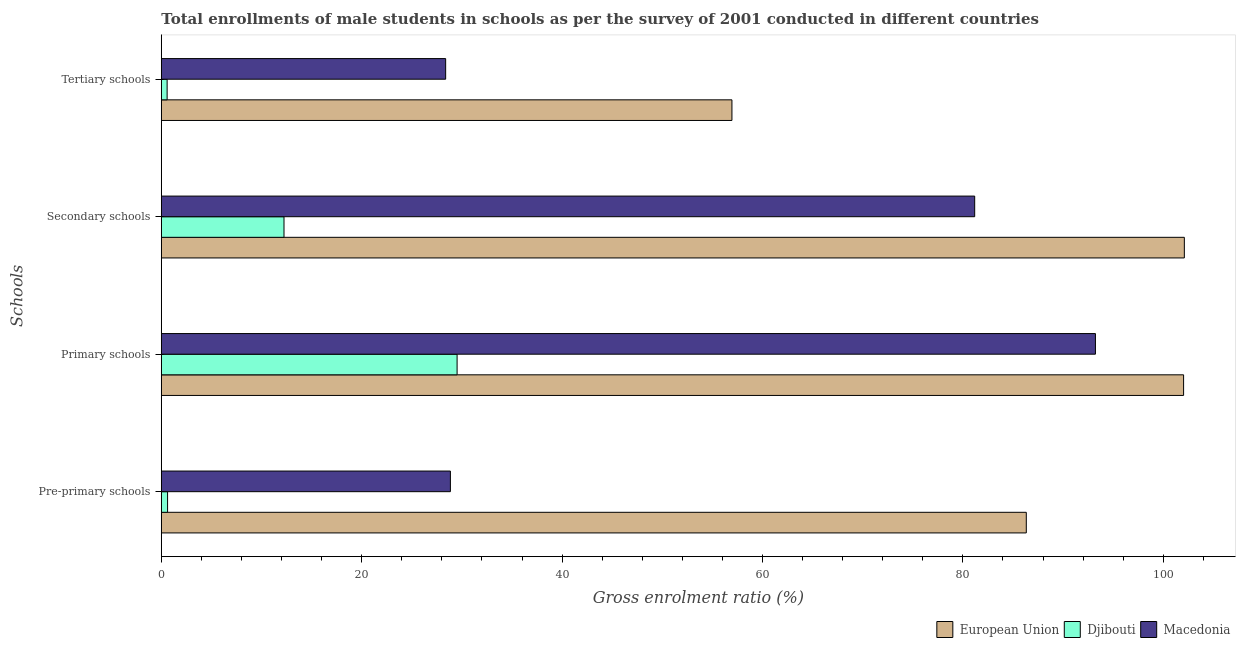How many groups of bars are there?
Offer a very short reply. 4. Are the number of bars per tick equal to the number of legend labels?
Give a very brief answer. Yes. Are the number of bars on each tick of the Y-axis equal?
Offer a terse response. Yes. How many bars are there on the 2nd tick from the top?
Offer a terse response. 3. How many bars are there on the 1st tick from the bottom?
Keep it short and to the point. 3. What is the label of the 1st group of bars from the top?
Give a very brief answer. Tertiary schools. What is the gross enrolment ratio(male) in pre-primary schools in Djibouti?
Offer a very short reply. 0.63. Across all countries, what is the maximum gross enrolment ratio(male) in pre-primary schools?
Keep it short and to the point. 86.33. Across all countries, what is the minimum gross enrolment ratio(male) in primary schools?
Keep it short and to the point. 29.52. In which country was the gross enrolment ratio(male) in primary schools maximum?
Provide a short and direct response. European Union. In which country was the gross enrolment ratio(male) in pre-primary schools minimum?
Provide a succinct answer. Djibouti. What is the total gross enrolment ratio(male) in pre-primary schools in the graph?
Offer a very short reply. 115.81. What is the difference between the gross enrolment ratio(male) in pre-primary schools in European Union and that in Djibouti?
Your answer should be compact. 85.71. What is the difference between the gross enrolment ratio(male) in secondary schools in Djibouti and the gross enrolment ratio(male) in tertiary schools in Macedonia?
Your response must be concise. -16.13. What is the average gross enrolment ratio(male) in primary schools per country?
Provide a short and direct response. 74.93. What is the difference between the gross enrolment ratio(male) in pre-primary schools and gross enrolment ratio(male) in primary schools in Macedonia?
Keep it short and to the point. -64.38. What is the ratio of the gross enrolment ratio(male) in pre-primary schools in European Union to that in Macedonia?
Your response must be concise. 2.99. What is the difference between the highest and the second highest gross enrolment ratio(male) in tertiary schools?
Your answer should be compact. 28.57. What is the difference between the highest and the lowest gross enrolment ratio(male) in tertiary schools?
Provide a short and direct response. 56.37. In how many countries, is the gross enrolment ratio(male) in tertiary schools greater than the average gross enrolment ratio(male) in tertiary schools taken over all countries?
Give a very brief answer. 1. What does the 2nd bar from the top in Pre-primary schools represents?
Your response must be concise. Djibouti. What does the 1st bar from the bottom in Pre-primary schools represents?
Make the answer very short. European Union. How many bars are there?
Provide a succinct answer. 12. Are all the bars in the graph horizontal?
Offer a very short reply. Yes. How many countries are there in the graph?
Provide a succinct answer. 3. Does the graph contain grids?
Your answer should be very brief. No. How many legend labels are there?
Give a very brief answer. 3. How are the legend labels stacked?
Offer a very short reply. Horizontal. What is the title of the graph?
Give a very brief answer. Total enrollments of male students in schools as per the survey of 2001 conducted in different countries. Does "Uganda" appear as one of the legend labels in the graph?
Provide a succinct answer. No. What is the label or title of the Y-axis?
Provide a short and direct response. Schools. What is the Gross enrolment ratio (%) of European Union in Pre-primary schools?
Your response must be concise. 86.33. What is the Gross enrolment ratio (%) of Djibouti in Pre-primary schools?
Give a very brief answer. 0.63. What is the Gross enrolment ratio (%) in Macedonia in Pre-primary schools?
Provide a succinct answer. 28.85. What is the Gross enrolment ratio (%) of European Union in Primary schools?
Provide a succinct answer. 102.03. What is the Gross enrolment ratio (%) of Djibouti in Primary schools?
Ensure brevity in your answer.  29.52. What is the Gross enrolment ratio (%) of Macedonia in Primary schools?
Your answer should be very brief. 93.23. What is the Gross enrolment ratio (%) of European Union in Secondary schools?
Provide a succinct answer. 102.11. What is the Gross enrolment ratio (%) of Djibouti in Secondary schools?
Give a very brief answer. 12.24. What is the Gross enrolment ratio (%) of Macedonia in Secondary schools?
Provide a succinct answer. 81.18. What is the Gross enrolment ratio (%) of European Union in Tertiary schools?
Give a very brief answer. 56.95. What is the Gross enrolment ratio (%) of Djibouti in Tertiary schools?
Your answer should be very brief. 0.58. What is the Gross enrolment ratio (%) of Macedonia in Tertiary schools?
Offer a terse response. 28.38. Across all Schools, what is the maximum Gross enrolment ratio (%) in European Union?
Keep it short and to the point. 102.11. Across all Schools, what is the maximum Gross enrolment ratio (%) of Djibouti?
Keep it short and to the point. 29.52. Across all Schools, what is the maximum Gross enrolment ratio (%) in Macedonia?
Your answer should be very brief. 93.23. Across all Schools, what is the minimum Gross enrolment ratio (%) in European Union?
Make the answer very short. 56.95. Across all Schools, what is the minimum Gross enrolment ratio (%) in Djibouti?
Offer a very short reply. 0.58. Across all Schools, what is the minimum Gross enrolment ratio (%) in Macedonia?
Offer a very short reply. 28.38. What is the total Gross enrolment ratio (%) in European Union in the graph?
Provide a succinct answer. 347.42. What is the total Gross enrolment ratio (%) of Djibouti in the graph?
Your response must be concise. 42.97. What is the total Gross enrolment ratio (%) in Macedonia in the graph?
Your answer should be compact. 231.64. What is the difference between the Gross enrolment ratio (%) in European Union in Pre-primary schools and that in Primary schools?
Offer a very short reply. -15.7. What is the difference between the Gross enrolment ratio (%) of Djibouti in Pre-primary schools and that in Primary schools?
Keep it short and to the point. -28.9. What is the difference between the Gross enrolment ratio (%) of Macedonia in Pre-primary schools and that in Primary schools?
Give a very brief answer. -64.38. What is the difference between the Gross enrolment ratio (%) of European Union in Pre-primary schools and that in Secondary schools?
Provide a succinct answer. -15.77. What is the difference between the Gross enrolment ratio (%) of Djibouti in Pre-primary schools and that in Secondary schools?
Your answer should be compact. -11.62. What is the difference between the Gross enrolment ratio (%) of Macedonia in Pre-primary schools and that in Secondary schools?
Keep it short and to the point. -52.33. What is the difference between the Gross enrolment ratio (%) in European Union in Pre-primary schools and that in Tertiary schools?
Keep it short and to the point. 29.38. What is the difference between the Gross enrolment ratio (%) of Djibouti in Pre-primary schools and that in Tertiary schools?
Provide a succinct answer. 0.05. What is the difference between the Gross enrolment ratio (%) in Macedonia in Pre-primary schools and that in Tertiary schools?
Provide a short and direct response. 0.47. What is the difference between the Gross enrolment ratio (%) of European Union in Primary schools and that in Secondary schools?
Provide a short and direct response. -0.07. What is the difference between the Gross enrolment ratio (%) in Djibouti in Primary schools and that in Secondary schools?
Keep it short and to the point. 17.28. What is the difference between the Gross enrolment ratio (%) of Macedonia in Primary schools and that in Secondary schools?
Keep it short and to the point. 12.05. What is the difference between the Gross enrolment ratio (%) of European Union in Primary schools and that in Tertiary schools?
Your answer should be compact. 45.08. What is the difference between the Gross enrolment ratio (%) in Djibouti in Primary schools and that in Tertiary schools?
Keep it short and to the point. 28.94. What is the difference between the Gross enrolment ratio (%) in Macedonia in Primary schools and that in Tertiary schools?
Provide a short and direct response. 64.85. What is the difference between the Gross enrolment ratio (%) in European Union in Secondary schools and that in Tertiary schools?
Your response must be concise. 45.15. What is the difference between the Gross enrolment ratio (%) of Djibouti in Secondary schools and that in Tertiary schools?
Offer a terse response. 11.66. What is the difference between the Gross enrolment ratio (%) of Macedonia in Secondary schools and that in Tertiary schools?
Your answer should be compact. 52.8. What is the difference between the Gross enrolment ratio (%) in European Union in Pre-primary schools and the Gross enrolment ratio (%) in Djibouti in Primary schools?
Give a very brief answer. 56.81. What is the difference between the Gross enrolment ratio (%) of European Union in Pre-primary schools and the Gross enrolment ratio (%) of Macedonia in Primary schools?
Offer a very short reply. -6.9. What is the difference between the Gross enrolment ratio (%) in Djibouti in Pre-primary schools and the Gross enrolment ratio (%) in Macedonia in Primary schools?
Provide a succinct answer. -92.61. What is the difference between the Gross enrolment ratio (%) in European Union in Pre-primary schools and the Gross enrolment ratio (%) in Djibouti in Secondary schools?
Provide a short and direct response. 74.09. What is the difference between the Gross enrolment ratio (%) of European Union in Pre-primary schools and the Gross enrolment ratio (%) of Macedonia in Secondary schools?
Your response must be concise. 5.15. What is the difference between the Gross enrolment ratio (%) of Djibouti in Pre-primary schools and the Gross enrolment ratio (%) of Macedonia in Secondary schools?
Provide a succinct answer. -80.56. What is the difference between the Gross enrolment ratio (%) in European Union in Pre-primary schools and the Gross enrolment ratio (%) in Djibouti in Tertiary schools?
Keep it short and to the point. 85.75. What is the difference between the Gross enrolment ratio (%) of European Union in Pre-primary schools and the Gross enrolment ratio (%) of Macedonia in Tertiary schools?
Make the answer very short. 57.95. What is the difference between the Gross enrolment ratio (%) in Djibouti in Pre-primary schools and the Gross enrolment ratio (%) in Macedonia in Tertiary schools?
Give a very brief answer. -27.75. What is the difference between the Gross enrolment ratio (%) in European Union in Primary schools and the Gross enrolment ratio (%) in Djibouti in Secondary schools?
Provide a succinct answer. 89.79. What is the difference between the Gross enrolment ratio (%) of European Union in Primary schools and the Gross enrolment ratio (%) of Macedonia in Secondary schools?
Give a very brief answer. 20.85. What is the difference between the Gross enrolment ratio (%) in Djibouti in Primary schools and the Gross enrolment ratio (%) in Macedonia in Secondary schools?
Offer a very short reply. -51.66. What is the difference between the Gross enrolment ratio (%) of European Union in Primary schools and the Gross enrolment ratio (%) of Djibouti in Tertiary schools?
Make the answer very short. 101.45. What is the difference between the Gross enrolment ratio (%) in European Union in Primary schools and the Gross enrolment ratio (%) in Macedonia in Tertiary schools?
Your answer should be compact. 73.65. What is the difference between the Gross enrolment ratio (%) in Djibouti in Primary schools and the Gross enrolment ratio (%) in Macedonia in Tertiary schools?
Ensure brevity in your answer.  1.14. What is the difference between the Gross enrolment ratio (%) in European Union in Secondary schools and the Gross enrolment ratio (%) in Djibouti in Tertiary schools?
Your answer should be compact. 101.53. What is the difference between the Gross enrolment ratio (%) in European Union in Secondary schools and the Gross enrolment ratio (%) in Macedonia in Tertiary schools?
Make the answer very short. 73.73. What is the difference between the Gross enrolment ratio (%) in Djibouti in Secondary schools and the Gross enrolment ratio (%) in Macedonia in Tertiary schools?
Make the answer very short. -16.13. What is the average Gross enrolment ratio (%) in European Union per Schools?
Provide a succinct answer. 86.86. What is the average Gross enrolment ratio (%) of Djibouti per Schools?
Make the answer very short. 10.74. What is the average Gross enrolment ratio (%) of Macedonia per Schools?
Ensure brevity in your answer.  57.91. What is the difference between the Gross enrolment ratio (%) of European Union and Gross enrolment ratio (%) of Djibouti in Pre-primary schools?
Make the answer very short. 85.71. What is the difference between the Gross enrolment ratio (%) of European Union and Gross enrolment ratio (%) of Macedonia in Pre-primary schools?
Offer a terse response. 57.48. What is the difference between the Gross enrolment ratio (%) of Djibouti and Gross enrolment ratio (%) of Macedonia in Pre-primary schools?
Keep it short and to the point. -28.23. What is the difference between the Gross enrolment ratio (%) of European Union and Gross enrolment ratio (%) of Djibouti in Primary schools?
Give a very brief answer. 72.51. What is the difference between the Gross enrolment ratio (%) of European Union and Gross enrolment ratio (%) of Macedonia in Primary schools?
Ensure brevity in your answer.  8.8. What is the difference between the Gross enrolment ratio (%) of Djibouti and Gross enrolment ratio (%) of Macedonia in Primary schools?
Your response must be concise. -63.71. What is the difference between the Gross enrolment ratio (%) in European Union and Gross enrolment ratio (%) in Djibouti in Secondary schools?
Provide a succinct answer. 89.86. What is the difference between the Gross enrolment ratio (%) of European Union and Gross enrolment ratio (%) of Macedonia in Secondary schools?
Ensure brevity in your answer.  20.93. What is the difference between the Gross enrolment ratio (%) of Djibouti and Gross enrolment ratio (%) of Macedonia in Secondary schools?
Offer a terse response. -68.94. What is the difference between the Gross enrolment ratio (%) in European Union and Gross enrolment ratio (%) in Djibouti in Tertiary schools?
Your answer should be very brief. 56.37. What is the difference between the Gross enrolment ratio (%) of European Union and Gross enrolment ratio (%) of Macedonia in Tertiary schools?
Your response must be concise. 28.57. What is the difference between the Gross enrolment ratio (%) of Djibouti and Gross enrolment ratio (%) of Macedonia in Tertiary schools?
Offer a terse response. -27.8. What is the ratio of the Gross enrolment ratio (%) in European Union in Pre-primary schools to that in Primary schools?
Your response must be concise. 0.85. What is the ratio of the Gross enrolment ratio (%) of Djibouti in Pre-primary schools to that in Primary schools?
Your answer should be very brief. 0.02. What is the ratio of the Gross enrolment ratio (%) in Macedonia in Pre-primary schools to that in Primary schools?
Give a very brief answer. 0.31. What is the ratio of the Gross enrolment ratio (%) of European Union in Pre-primary schools to that in Secondary schools?
Your answer should be very brief. 0.85. What is the ratio of the Gross enrolment ratio (%) of Djibouti in Pre-primary schools to that in Secondary schools?
Your response must be concise. 0.05. What is the ratio of the Gross enrolment ratio (%) in Macedonia in Pre-primary schools to that in Secondary schools?
Keep it short and to the point. 0.36. What is the ratio of the Gross enrolment ratio (%) in European Union in Pre-primary schools to that in Tertiary schools?
Provide a short and direct response. 1.52. What is the ratio of the Gross enrolment ratio (%) of Djibouti in Pre-primary schools to that in Tertiary schools?
Provide a succinct answer. 1.08. What is the ratio of the Gross enrolment ratio (%) of Macedonia in Pre-primary schools to that in Tertiary schools?
Keep it short and to the point. 1.02. What is the ratio of the Gross enrolment ratio (%) of Djibouti in Primary schools to that in Secondary schools?
Ensure brevity in your answer.  2.41. What is the ratio of the Gross enrolment ratio (%) in Macedonia in Primary schools to that in Secondary schools?
Make the answer very short. 1.15. What is the ratio of the Gross enrolment ratio (%) in European Union in Primary schools to that in Tertiary schools?
Give a very brief answer. 1.79. What is the ratio of the Gross enrolment ratio (%) in Djibouti in Primary schools to that in Tertiary schools?
Provide a succinct answer. 50.9. What is the ratio of the Gross enrolment ratio (%) of Macedonia in Primary schools to that in Tertiary schools?
Your response must be concise. 3.29. What is the ratio of the Gross enrolment ratio (%) of European Union in Secondary schools to that in Tertiary schools?
Give a very brief answer. 1.79. What is the ratio of the Gross enrolment ratio (%) of Djibouti in Secondary schools to that in Tertiary schools?
Your answer should be compact. 21.11. What is the ratio of the Gross enrolment ratio (%) in Macedonia in Secondary schools to that in Tertiary schools?
Offer a terse response. 2.86. What is the difference between the highest and the second highest Gross enrolment ratio (%) in European Union?
Make the answer very short. 0.07. What is the difference between the highest and the second highest Gross enrolment ratio (%) in Djibouti?
Your answer should be very brief. 17.28. What is the difference between the highest and the second highest Gross enrolment ratio (%) of Macedonia?
Keep it short and to the point. 12.05. What is the difference between the highest and the lowest Gross enrolment ratio (%) of European Union?
Give a very brief answer. 45.15. What is the difference between the highest and the lowest Gross enrolment ratio (%) of Djibouti?
Keep it short and to the point. 28.94. What is the difference between the highest and the lowest Gross enrolment ratio (%) of Macedonia?
Make the answer very short. 64.85. 